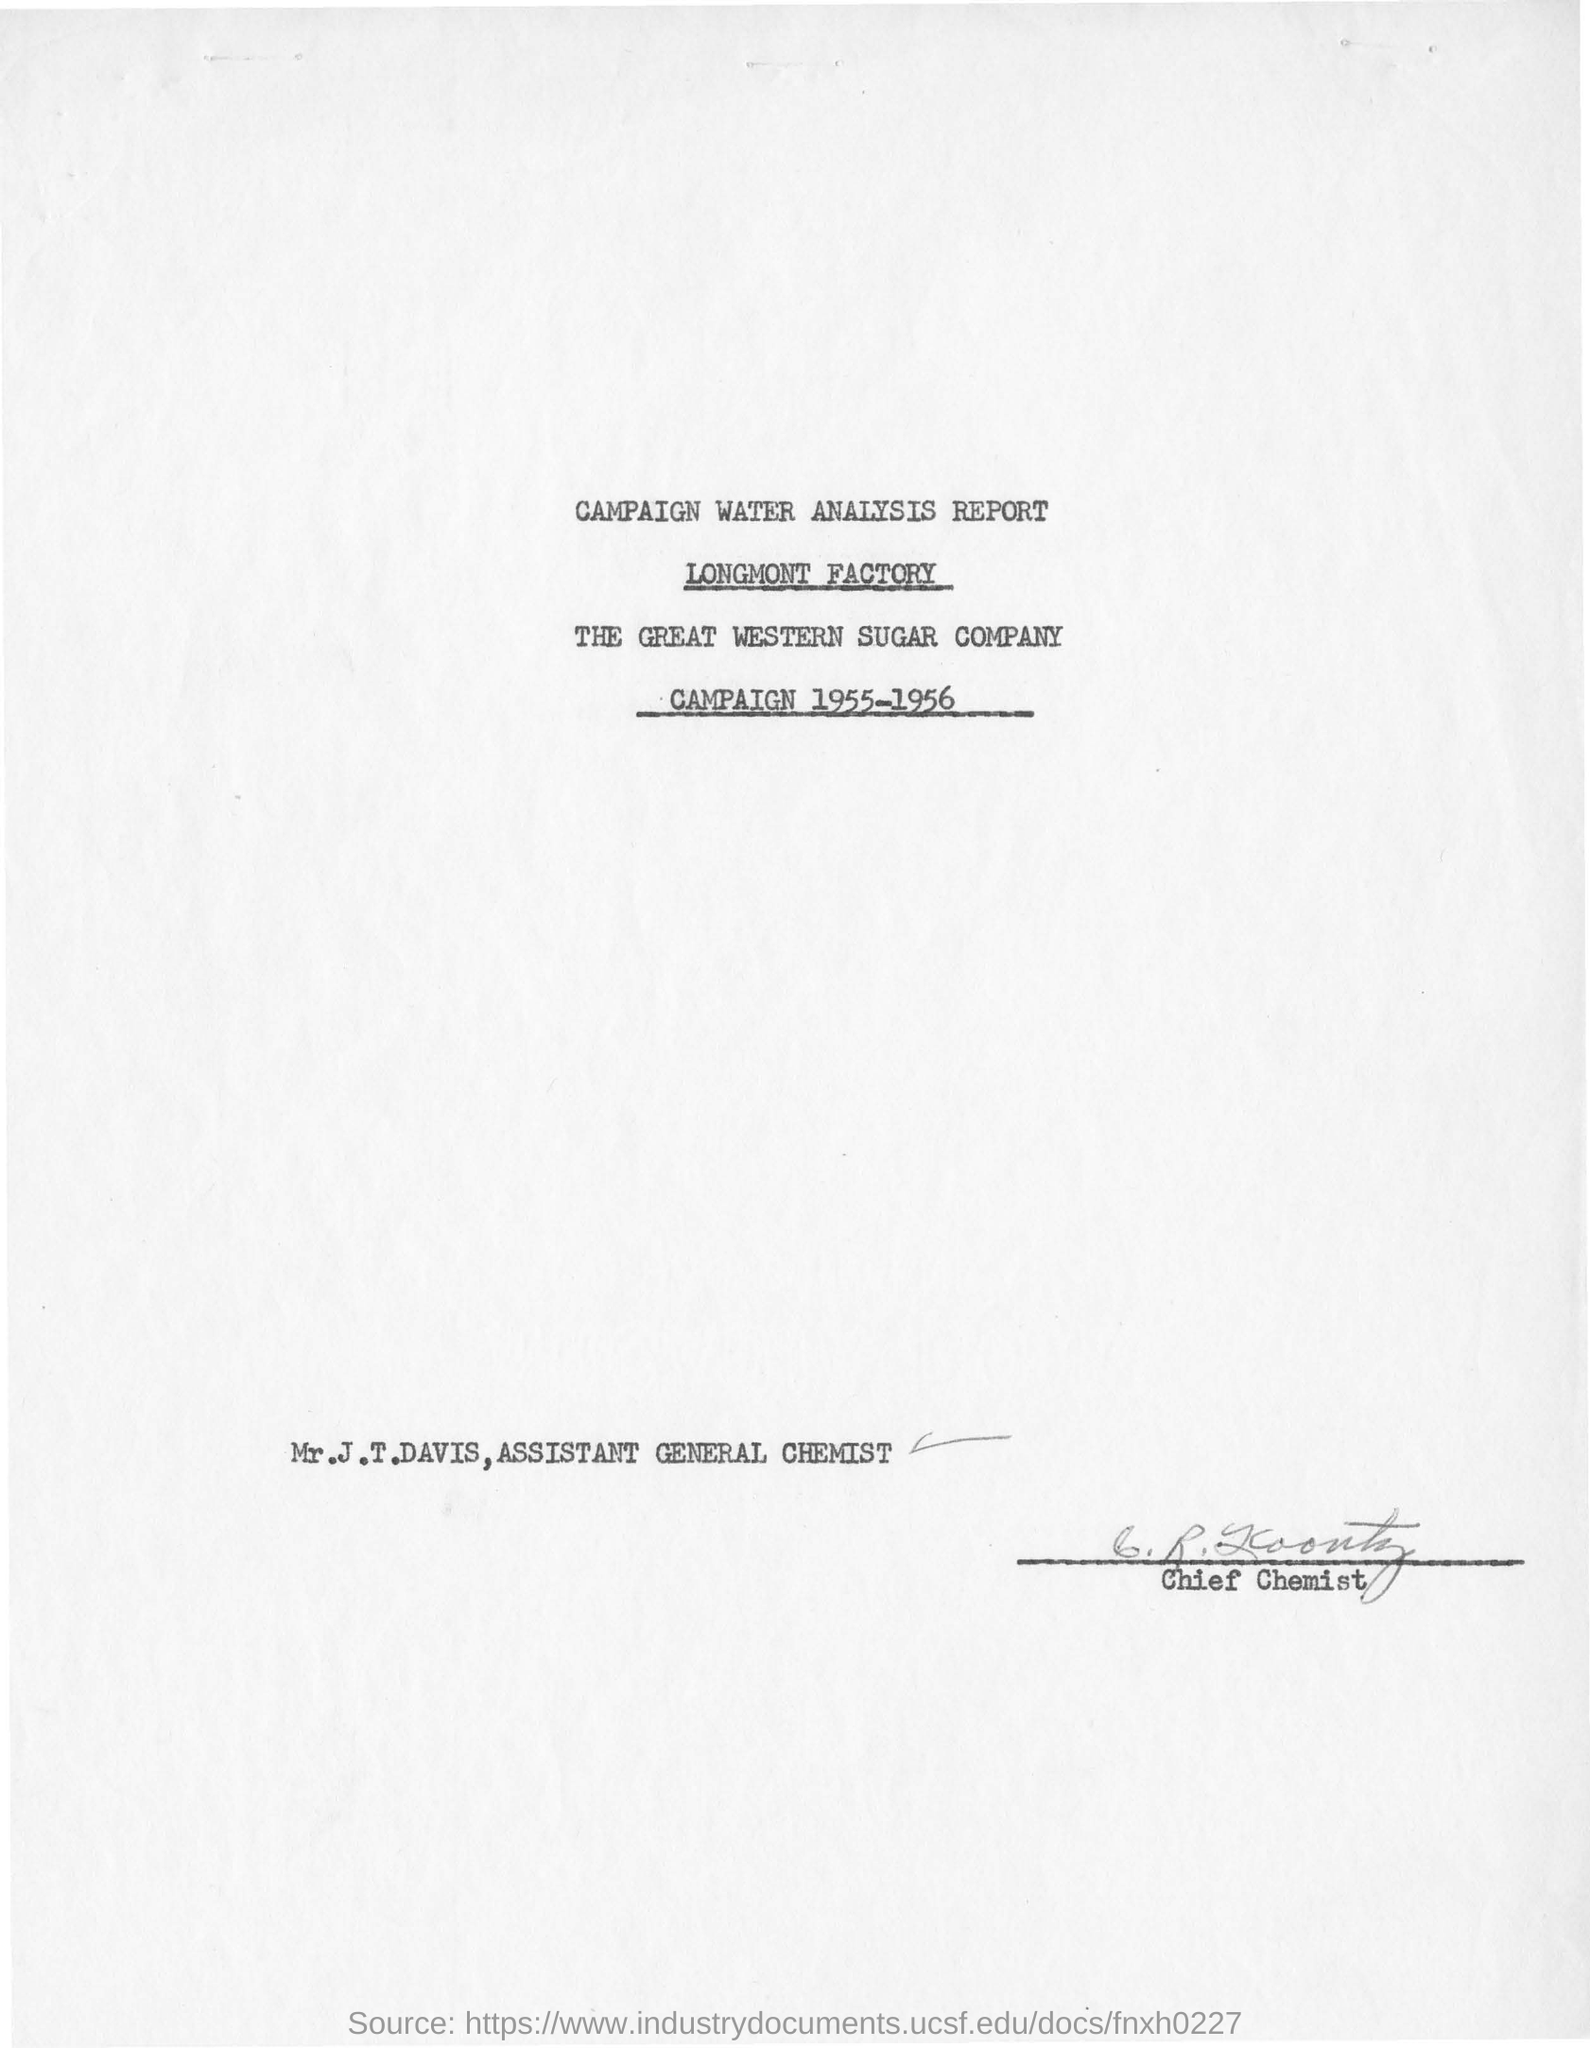Indicate a few pertinent items in this graphic. The factory name is LONGMONT. Mr. J.T. Davis is the Assistant General Chemist. The title of the document is the Campaign Water Analysis Report. The year mentioned in the document is 1955-1956. 